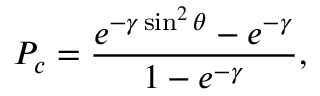<formula> <loc_0><loc_0><loc_500><loc_500>P _ { c } = { \frac { e ^ { - \gamma \sin ^ { 2 } \theta } - e ^ { - \gamma } } { 1 - e ^ { - \gamma } } } ,</formula> 